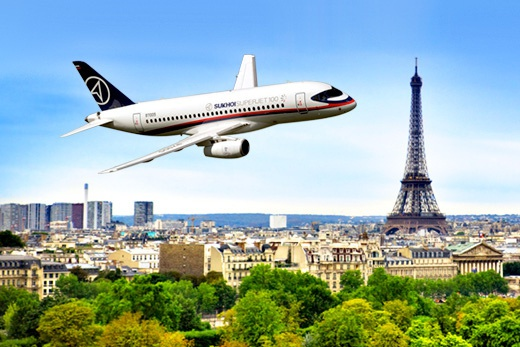Describe the objects in this image and their specific colors. I can see a airplane in lightblue, white, black, and darkgray tones in this image. 